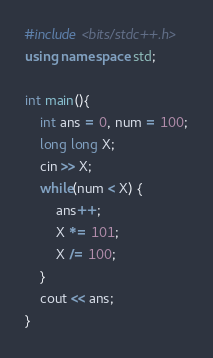Convert code to text. <code><loc_0><loc_0><loc_500><loc_500><_C++_>#include <bits/stdc++.h>
using namespace std;

int main(){
    int ans = 0, num = 100;
    long long X;
    cin >> X;
    while(num < X) {
        ans++;
        X *= 101;
        X /= 100;
    }
    cout << ans;
} </code> 